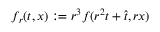<formula> <loc_0><loc_0><loc_500><loc_500>f _ { r } ( t , x ) \colon = r ^ { 3 } f ( r ^ { 2 } t + \hat { t } , r x )</formula> 